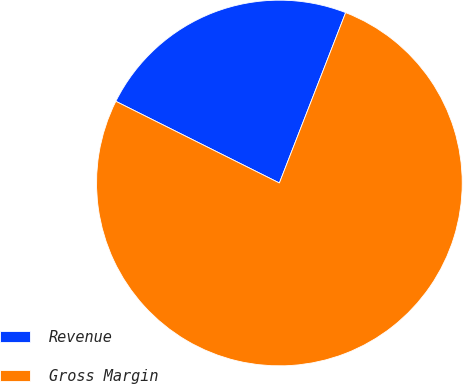Convert chart. <chart><loc_0><loc_0><loc_500><loc_500><pie_chart><fcel>Revenue<fcel>Gross Margin<nl><fcel>23.53%<fcel>76.47%<nl></chart> 